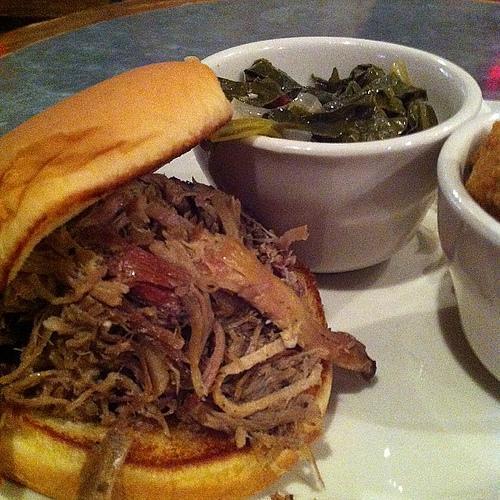How many bowls are in the picture?
Give a very brief answer. 2. 